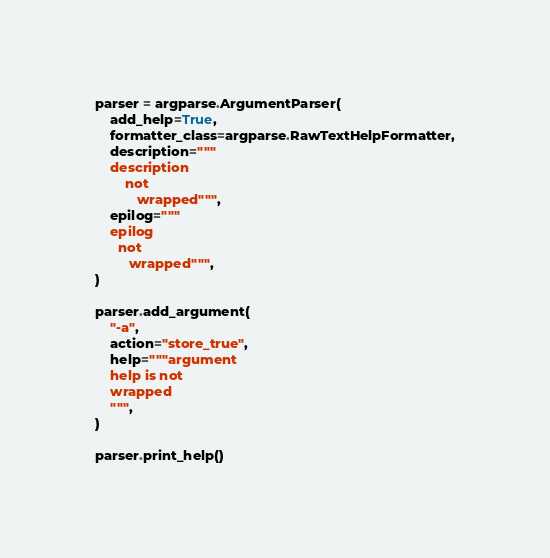<code> <loc_0><loc_0><loc_500><loc_500><_Python_>parser = argparse.ArgumentParser(
    add_help=True,
    formatter_class=argparse.RawTextHelpFormatter,
    description="""
    description
        not
           wrapped""",
    epilog="""
    epilog
      not
         wrapped""",
)

parser.add_argument(
    "-a",
    action="store_true",
    help="""argument
    help is not
    wrapped
    """,
)

parser.print_help()
</code> 